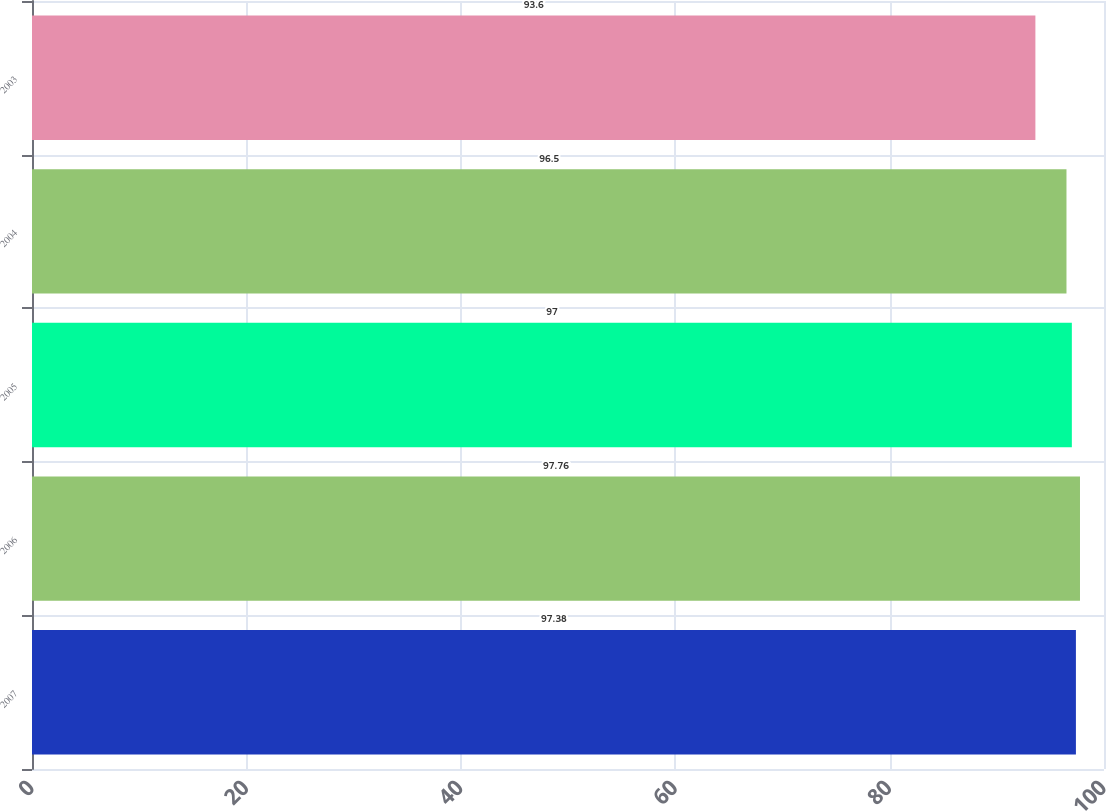Convert chart to OTSL. <chart><loc_0><loc_0><loc_500><loc_500><bar_chart><fcel>2007<fcel>2006<fcel>2005<fcel>2004<fcel>2003<nl><fcel>97.38<fcel>97.76<fcel>97<fcel>96.5<fcel>93.6<nl></chart> 